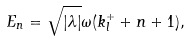Convert formula to latex. <formula><loc_0><loc_0><loc_500><loc_500>E _ { n } = \sqrt { | \lambda | } \omega ( k ^ { + } _ { l } + n + 1 ) ,</formula> 